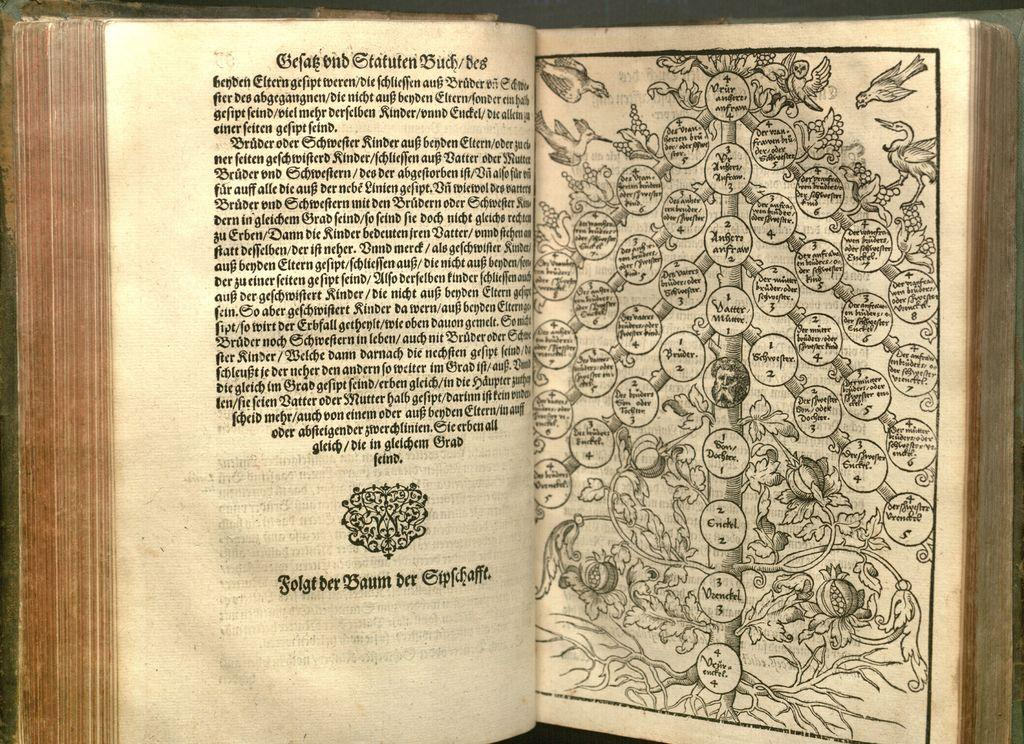<image>
Relay a brief, clear account of the picture shown. A book on hierarchical statutes written in German. 